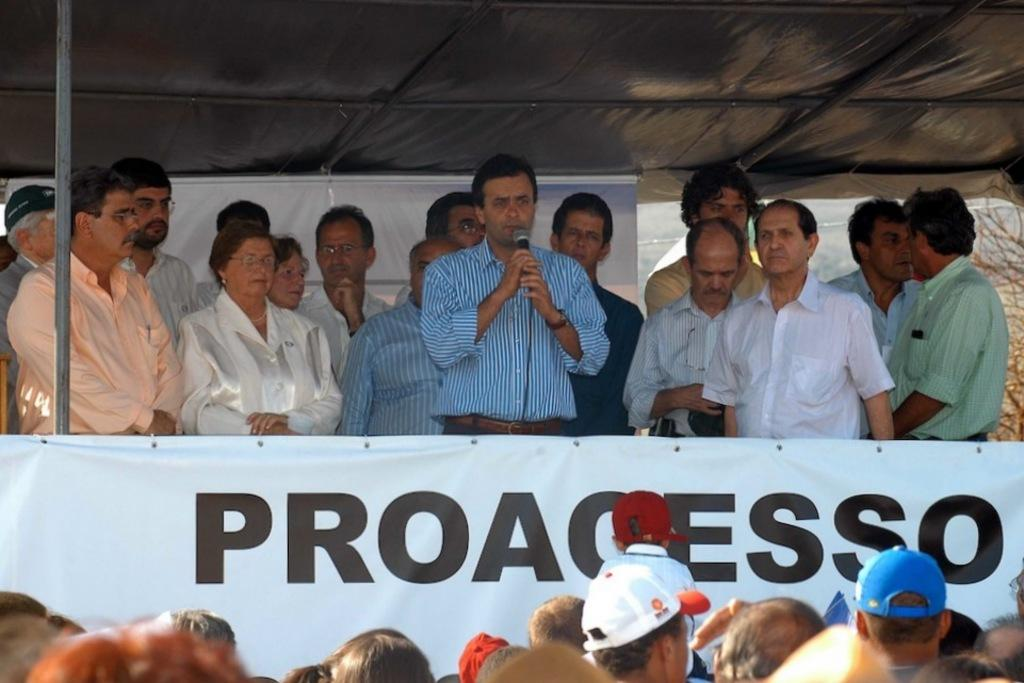What is the man in the middle of the image doing? The man is standing in the middle of the image and speaking into a microphone. Who else is present in the image? There is a woman standing on the left side of the image. What is the woman wearing? The woman is wearing a white dress. Are there any other people in the image? Yes, there are men standing around the woman. What type of vacation is the man planning based on the image? There is no information about a vacation in the image, as it primarily focuses on the man speaking into a microphone and the woman standing nearby. 